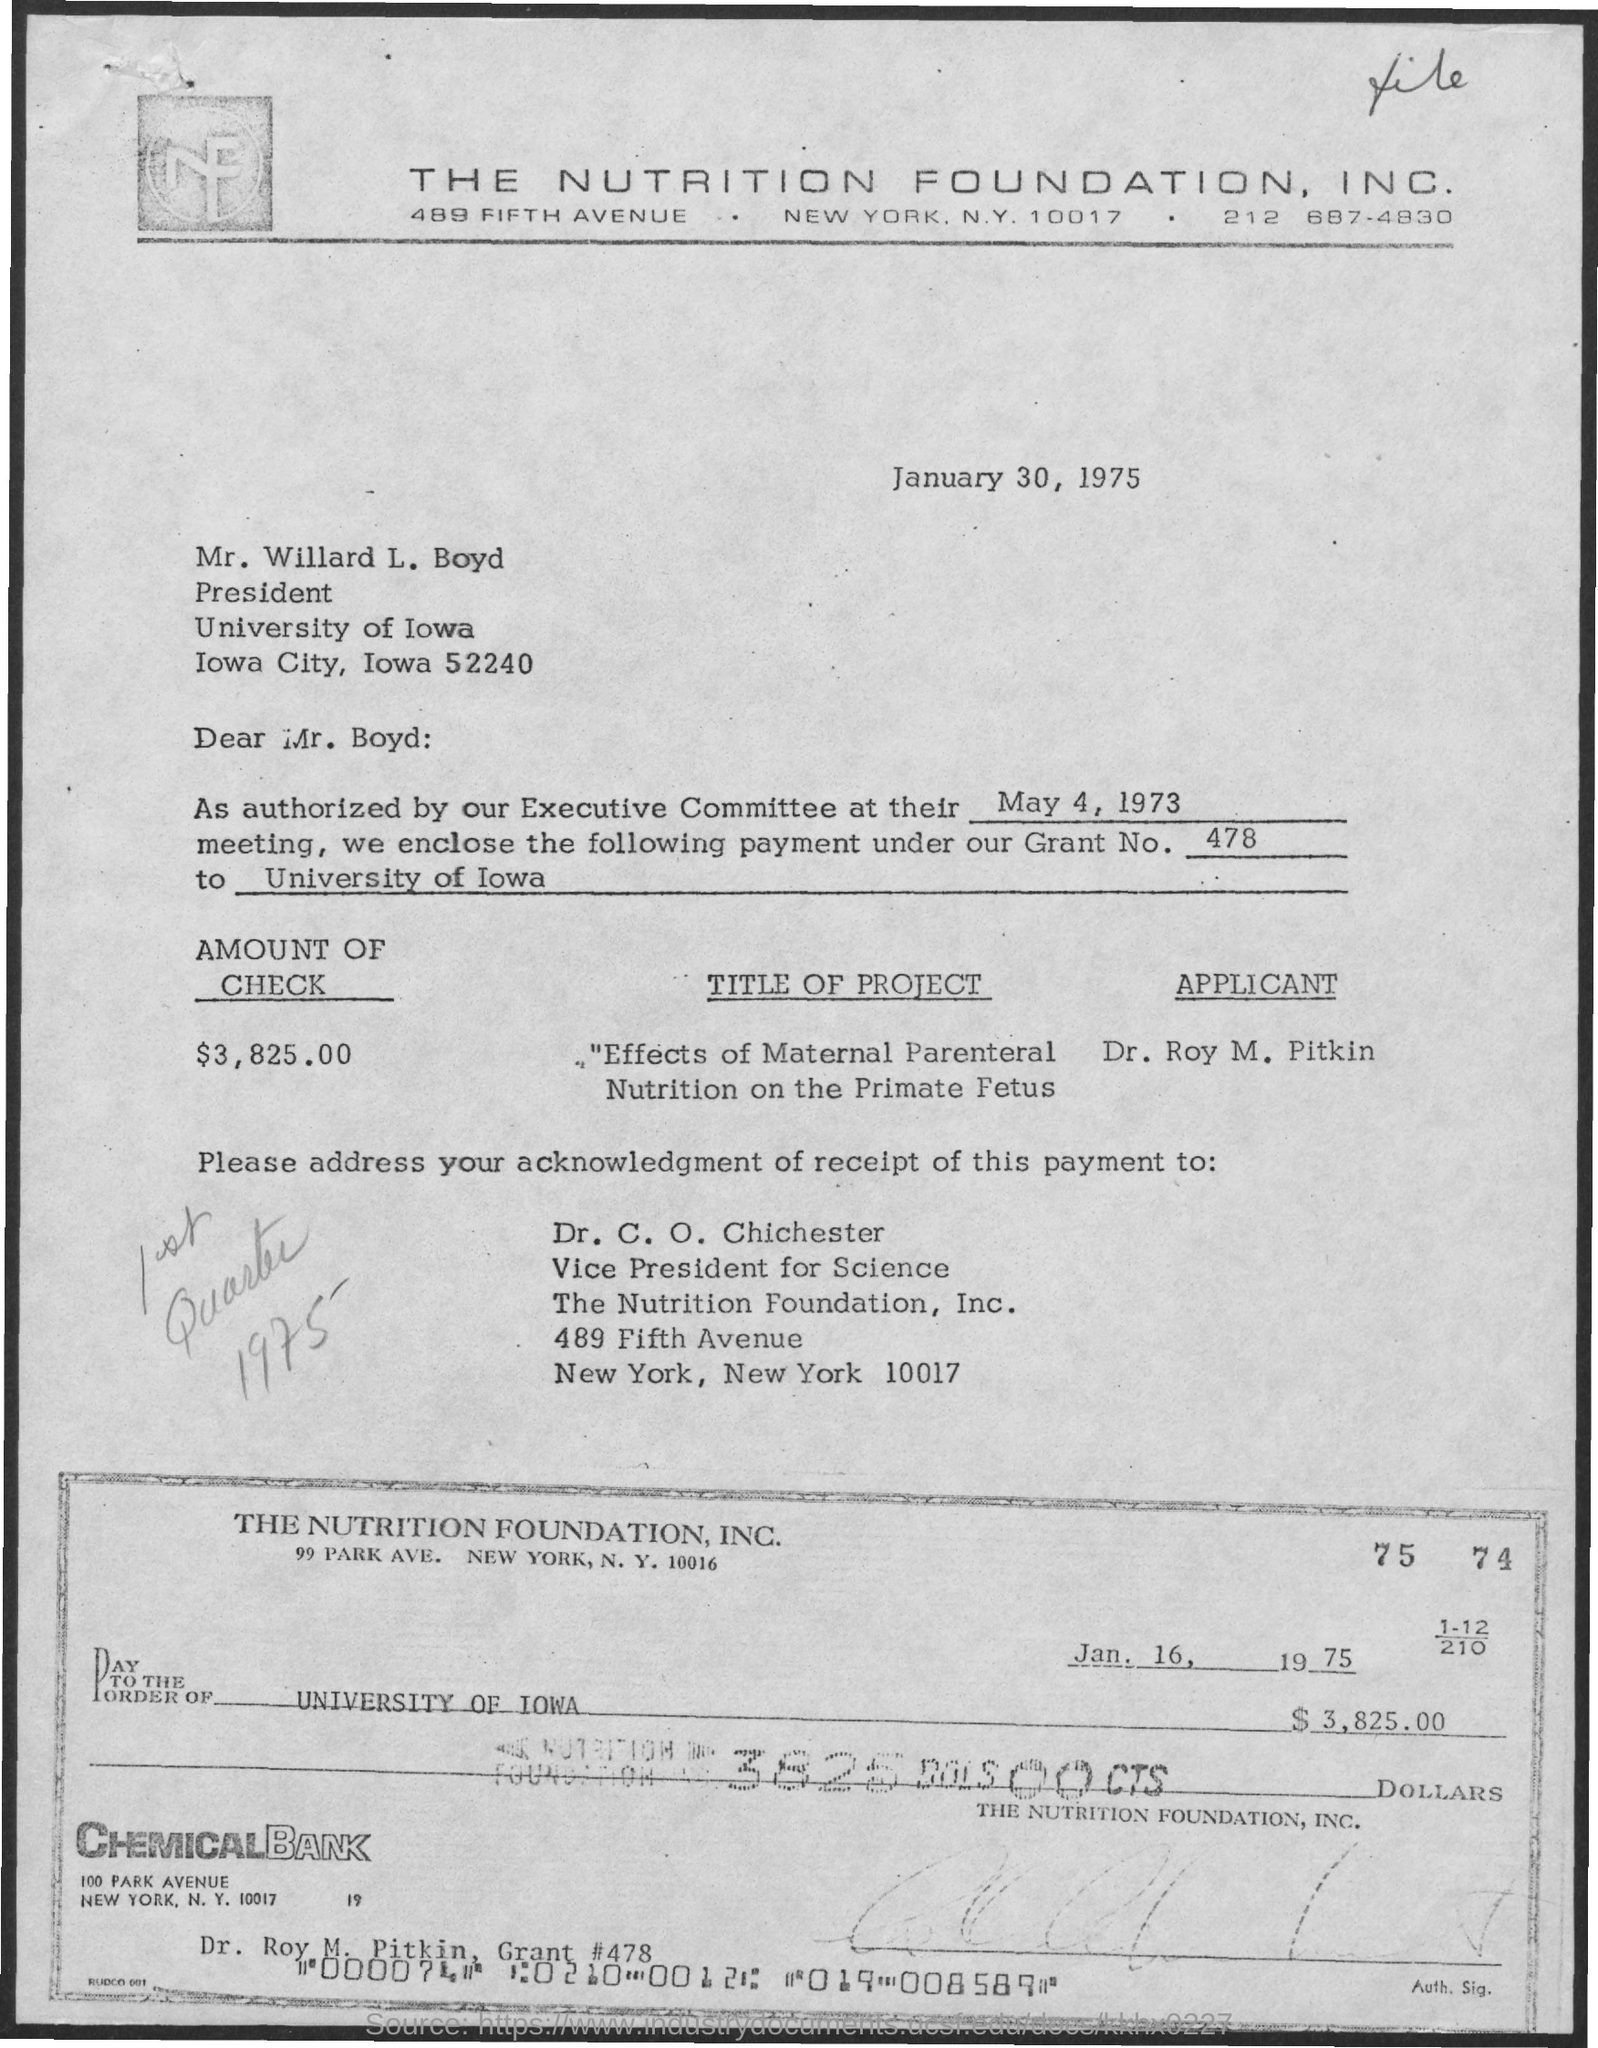Point out several critical features in this image. The grant number mentioned in the given letter is Grant No. 478. The date mentioned in the given check is January 16, 1975. The title of the project described in the letter is "The Effects of Maternal Parenteral Nutrition on the Fetus in Primates. The amount of the check mentioned in the letter is $3,825.00. 